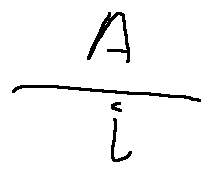Convert formula to latex. <formula><loc_0><loc_0><loc_500><loc_500>\frac { A } { i }</formula> 